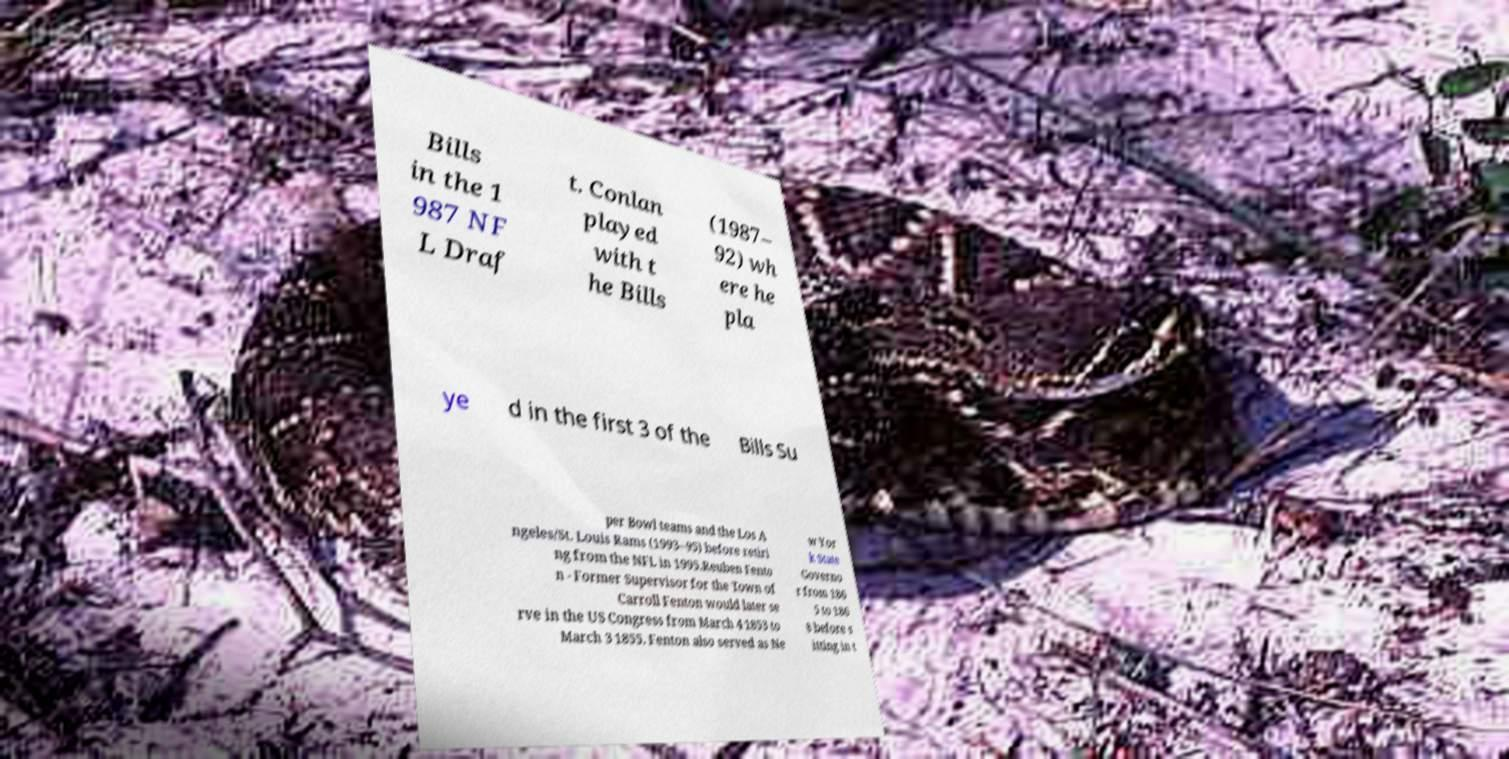Can you accurately transcribe the text from the provided image for me? Bills in the 1 987 NF L Draf t. Conlan played with t he Bills (1987– 92) wh ere he pla ye d in the first 3 of the Bills Su per Bowl teams and the Los A ngeles/St. Louis Rams (1993–95) before retiri ng from the NFL in 1995.Reuben Fento n - Former Supervisor for the Town of Carroll Fenton would later se rve in the US Congress from March 4 1853 to March 3 1855. Fenton also served as Ne w Yor k State Governo r from 186 5 to 186 8 before s itting in t 